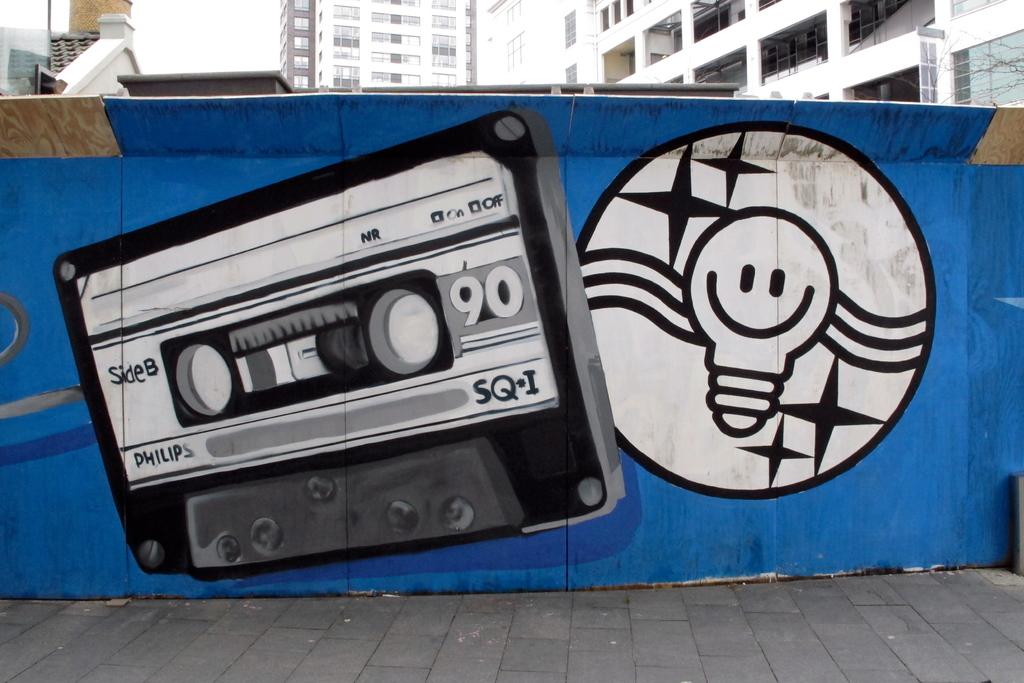What is hanging on the wall in the image? There is a painting on the wall in the image. What can be seen in the distance in the image? There are big buildings in the background of the image. What type of oatmeal is being served in the image? There is no oatmeal present in the image. What kind of beast can be seen roaming around in the image? There is no beast present in the image. 